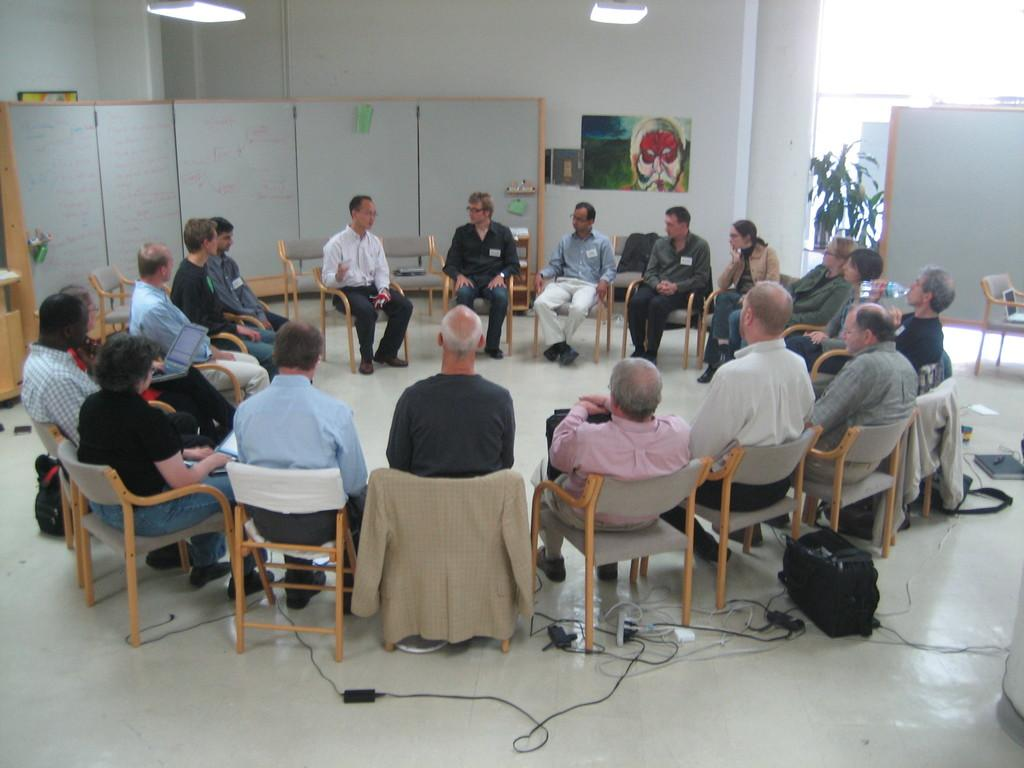How many people are in the image? There is a group of people in the image. What are the people doing in the image? The people are sitting on chairs. What can be seen in the background of the image? There is a wall, a painting, a plant, and lights in the ceiling in the background of the image. What type of milk is being traded in the image? There is no mention of milk or trade in the image; it features a group of people sitting on chairs with a background containing a wall, a painting, a plant, and lights in the ceiling. 